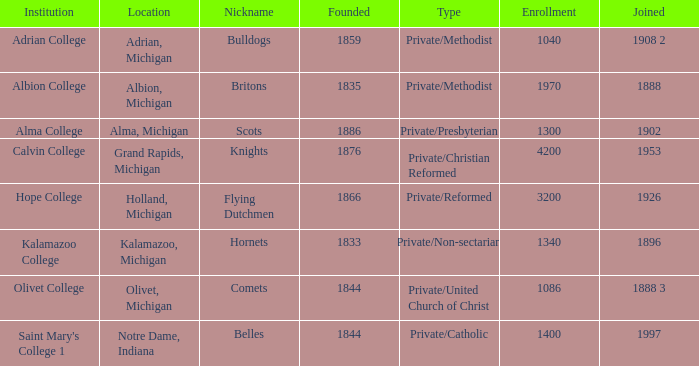Which institutions can be categorized as private/united church of christ? Olivet College. 